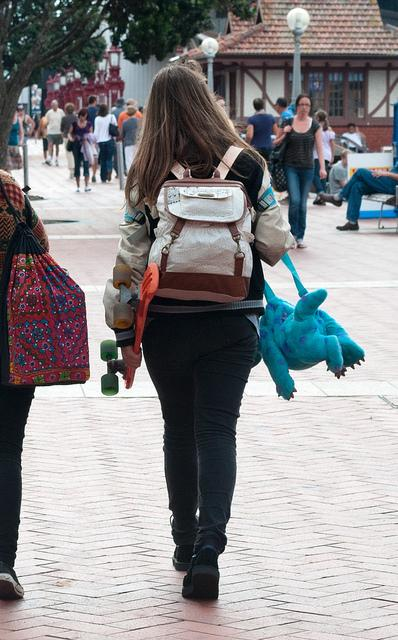What is the dominate color of the object the woman is carrying with her left arm?

Choices:
A) pink
B) red
C) orange
D) purple orange 